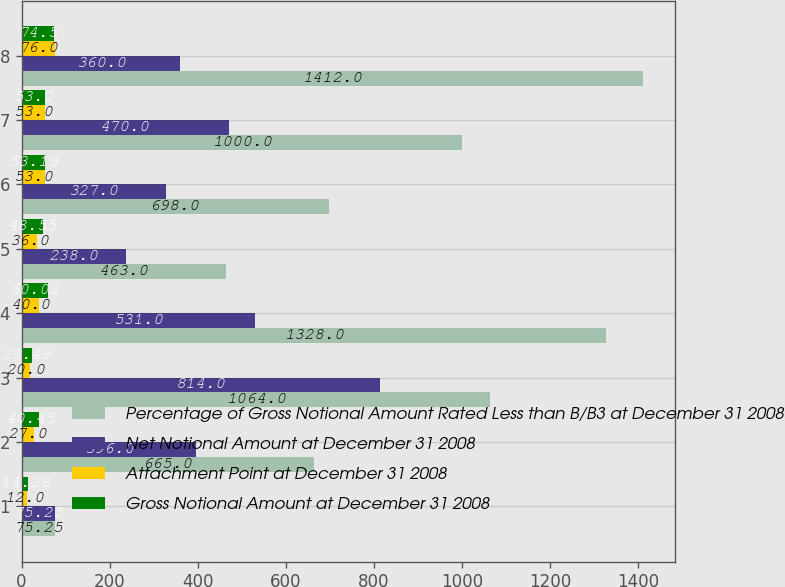Convert chart. <chart><loc_0><loc_0><loc_500><loc_500><stacked_bar_chart><ecel><fcel>1<fcel>2<fcel>3<fcel>4<fcel>5<fcel>6<fcel>7<fcel>8<nl><fcel>Percentage of Gross Notional Amount Rated Less than B/B3 at December 31 2008<fcel>75.25<fcel>665<fcel>1064<fcel>1328<fcel>463<fcel>698<fcel>1000<fcel>1412<nl><fcel>Net Notional Amount at December 31 2008<fcel>75.25<fcel>396<fcel>814<fcel>531<fcel>238<fcel>327<fcel>470<fcel>360<nl><fcel>Attachment Point at December 31 2008<fcel>12<fcel>27<fcel>20<fcel>40<fcel>36<fcel>53<fcel>53<fcel>76<nl><fcel>Gross Notional Amount at December 31 2008<fcel>14.28<fcel>40.45<fcel>23.49<fcel>60.02<fcel>48.55<fcel>53.19<fcel>53<fcel>74.5<nl></chart> 